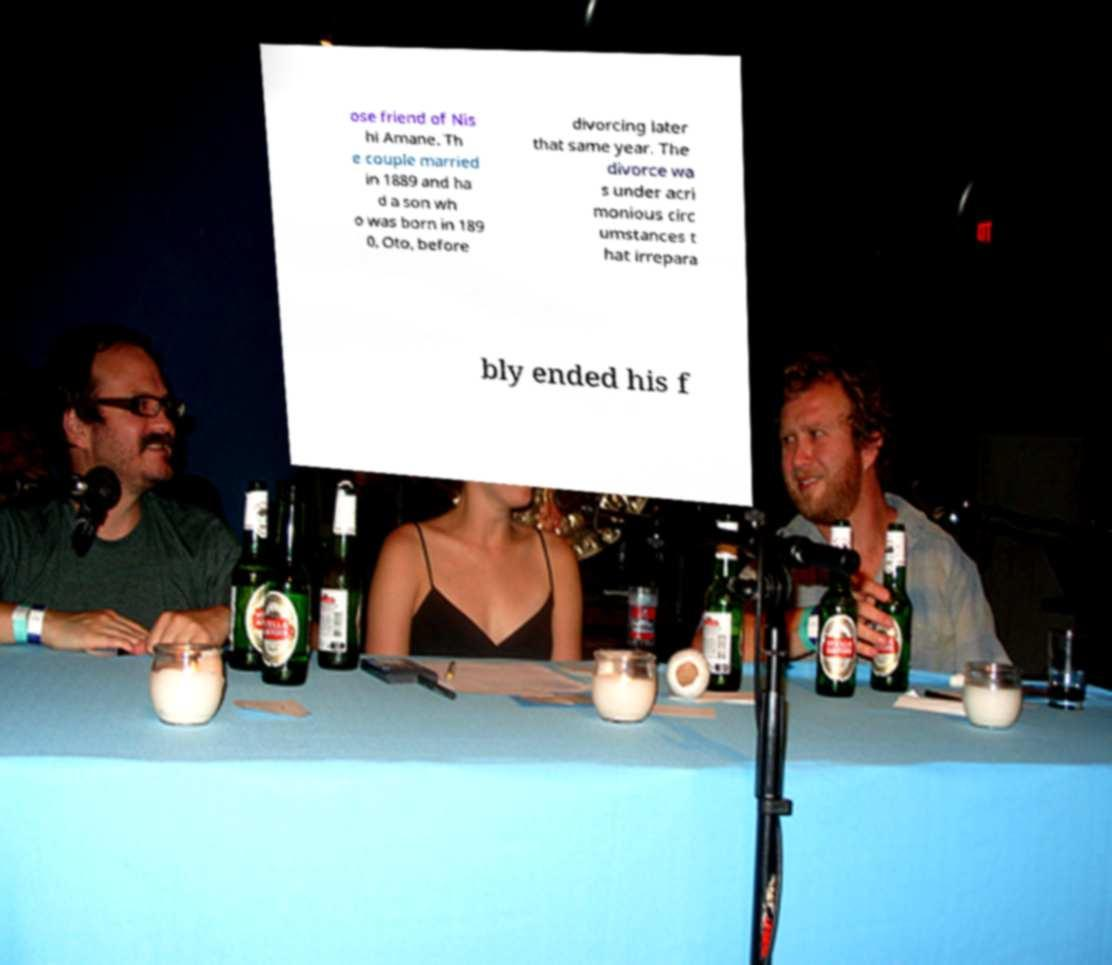Can you read and provide the text displayed in the image?This photo seems to have some interesting text. Can you extract and type it out for me? ose friend of Nis hi Amane. Th e couple married in 1889 and ha d a son wh o was born in 189 0, Oto, before divorcing later that same year. The divorce wa s under acri monious circ umstances t hat irrepara bly ended his f 